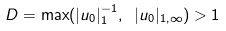<formula> <loc_0><loc_0><loc_500><loc_500>D = \max ( | u _ { 0 } | _ { 1 } ^ { - 1 } , \ | u _ { 0 } | _ { 1 , \infty } ) > 1</formula> 